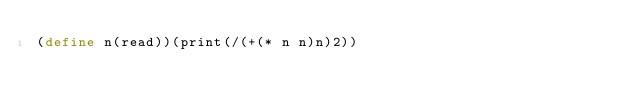Convert code to text. <code><loc_0><loc_0><loc_500><loc_500><_Scheme_>(define n(read))(print(/(+(* n n)n)2))</code> 